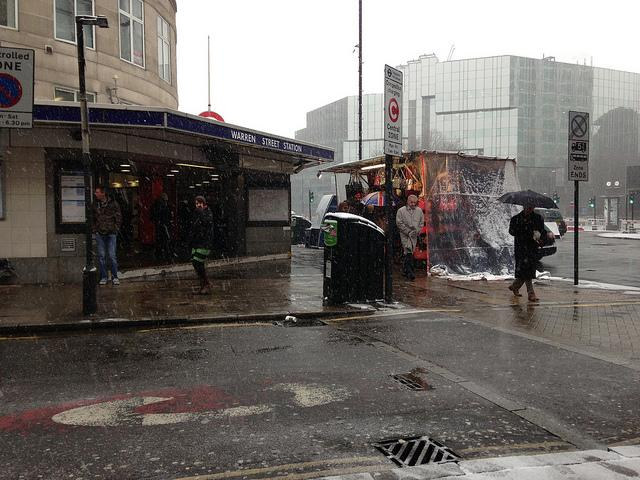What does the item the person on the far right is holding protect against?

Choices:
A) rain
B) vampires
C) bears
D) mosquitos rain 